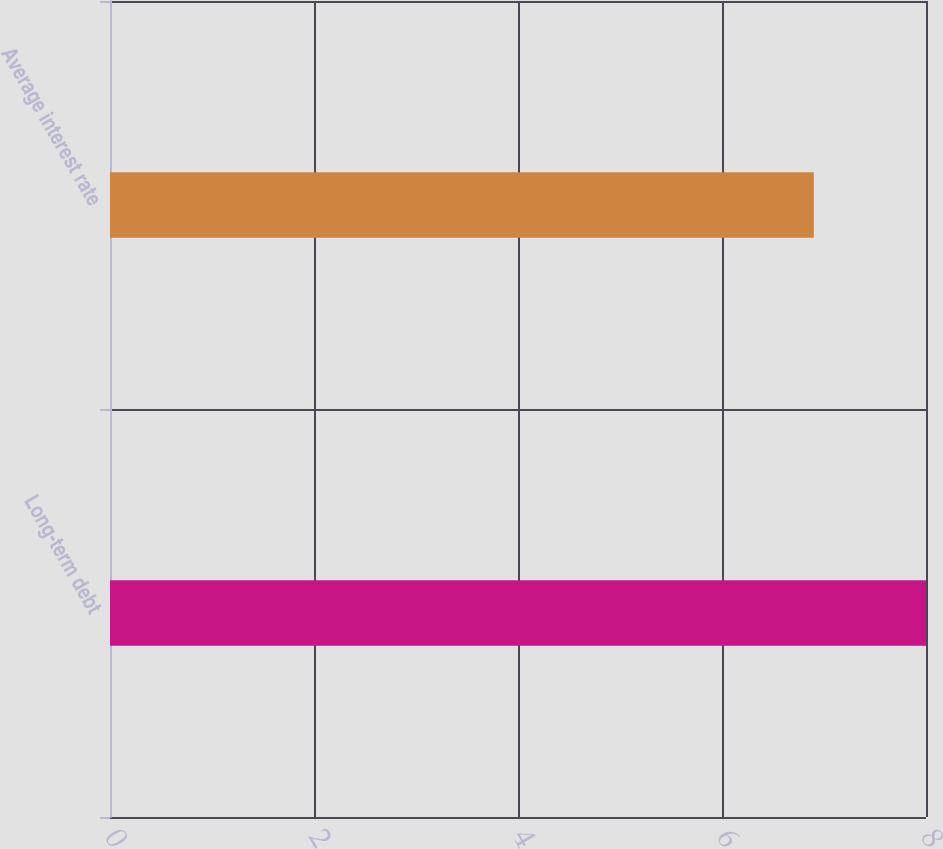Convert chart. <chart><loc_0><loc_0><loc_500><loc_500><bar_chart><fcel>Long-term debt<fcel>Average interest rate<nl><fcel>8<fcel>6.9<nl></chart> 